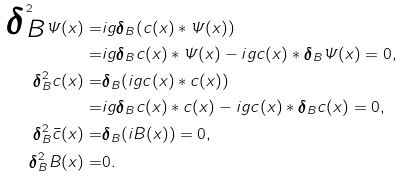<formula> <loc_0><loc_0><loc_500><loc_500>\boldsymbol \delta _ { \text {$ B$} } ^ { 2 } { \mathit \Psi } ( x ) = & i g \boldsymbol \delta _ { \text {$ B$} } ( c ( x ) \ast { \mathit \Psi } ( x ) ) \\ = & i g \boldsymbol \delta _ { \text {$ B$} } c ( x ) \ast { \mathit \Psi } ( x ) - i g c ( x ) \ast \boldsymbol \delta _ { \text {$ B$} } { \mathit \Psi } ( x ) = 0 , \\ \boldsymbol \delta _ { \text {$ B$} } ^ { 2 } c ( x ) = & \boldsymbol \delta _ { \text {$ B$} } ( i g c ( x ) \ast c ( x ) ) \\ = & i g \boldsymbol \delta _ { \text {$ B$} } c ( x ) \ast c ( x ) - i g c ( x ) \ast \boldsymbol \delta _ { \text {$ B$} } c ( x ) = 0 , \\ \boldsymbol \delta _ { \text {$ B$} } ^ { 2 } { \bar { c } ( x ) } = & \boldsymbol \delta _ { \text {$ B$} } ( i B ( x ) ) = 0 , \\ \boldsymbol \delta _ { \text {$ B$} } ^ { 2 } B ( x ) = & 0 .</formula> 